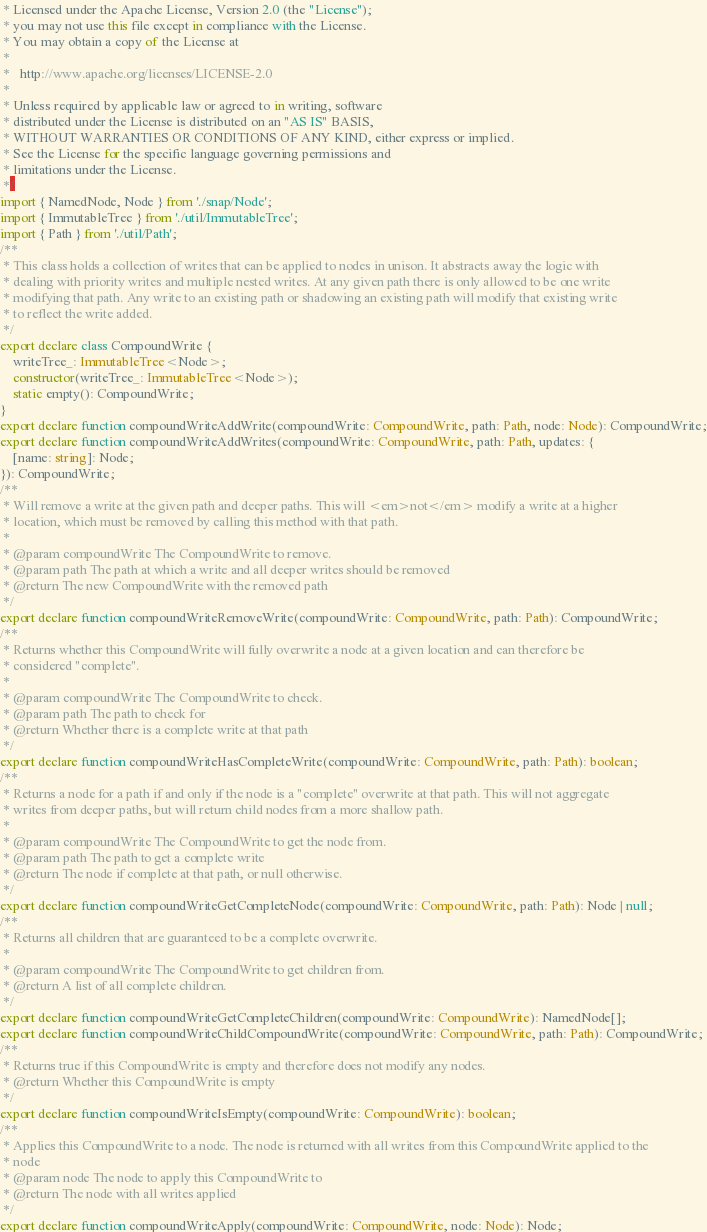Convert code to text. <code><loc_0><loc_0><loc_500><loc_500><_TypeScript_> * Licensed under the Apache License, Version 2.0 (the "License");
 * you may not use this file except in compliance with the License.
 * You may obtain a copy of the License at
 *
 *   http://www.apache.org/licenses/LICENSE-2.0
 *
 * Unless required by applicable law or agreed to in writing, software
 * distributed under the License is distributed on an "AS IS" BASIS,
 * WITHOUT WARRANTIES OR CONDITIONS OF ANY KIND, either express or implied.
 * See the License for the specific language governing permissions and
 * limitations under the License.
 */
import { NamedNode, Node } from './snap/Node';
import { ImmutableTree } from './util/ImmutableTree';
import { Path } from './util/Path';
/**
 * This class holds a collection of writes that can be applied to nodes in unison. It abstracts away the logic with
 * dealing with priority writes and multiple nested writes. At any given path there is only allowed to be one write
 * modifying that path. Any write to an existing path or shadowing an existing path will modify that existing write
 * to reflect the write added.
 */
export declare class CompoundWrite {
    writeTree_: ImmutableTree<Node>;
    constructor(writeTree_: ImmutableTree<Node>);
    static empty(): CompoundWrite;
}
export declare function compoundWriteAddWrite(compoundWrite: CompoundWrite, path: Path, node: Node): CompoundWrite;
export declare function compoundWriteAddWrites(compoundWrite: CompoundWrite, path: Path, updates: {
    [name: string]: Node;
}): CompoundWrite;
/**
 * Will remove a write at the given path and deeper paths. This will <em>not</em> modify a write at a higher
 * location, which must be removed by calling this method with that path.
 *
 * @param compoundWrite The CompoundWrite to remove.
 * @param path The path at which a write and all deeper writes should be removed
 * @return The new CompoundWrite with the removed path
 */
export declare function compoundWriteRemoveWrite(compoundWrite: CompoundWrite, path: Path): CompoundWrite;
/**
 * Returns whether this CompoundWrite will fully overwrite a node at a given location and can therefore be
 * considered "complete".
 *
 * @param compoundWrite The CompoundWrite to check.
 * @param path The path to check for
 * @return Whether there is a complete write at that path
 */
export declare function compoundWriteHasCompleteWrite(compoundWrite: CompoundWrite, path: Path): boolean;
/**
 * Returns a node for a path if and only if the node is a "complete" overwrite at that path. This will not aggregate
 * writes from deeper paths, but will return child nodes from a more shallow path.
 *
 * @param compoundWrite The CompoundWrite to get the node from.
 * @param path The path to get a complete write
 * @return The node if complete at that path, or null otherwise.
 */
export declare function compoundWriteGetCompleteNode(compoundWrite: CompoundWrite, path: Path): Node | null;
/**
 * Returns all children that are guaranteed to be a complete overwrite.
 *
 * @param compoundWrite The CompoundWrite to get children from.
 * @return A list of all complete children.
 */
export declare function compoundWriteGetCompleteChildren(compoundWrite: CompoundWrite): NamedNode[];
export declare function compoundWriteChildCompoundWrite(compoundWrite: CompoundWrite, path: Path): CompoundWrite;
/**
 * Returns true if this CompoundWrite is empty and therefore does not modify any nodes.
 * @return Whether this CompoundWrite is empty
 */
export declare function compoundWriteIsEmpty(compoundWrite: CompoundWrite): boolean;
/**
 * Applies this CompoundWrite to a node. The node is returned with all writes from this CompoundWrite applied to the
 * node
 * @param node The node to apply this CompoundWrite to
 * @return The node with all writes applied
 */
export declare function compoundWriteApply(compoundWrite: CompoundWrite, node: Node): Node;
</code> 